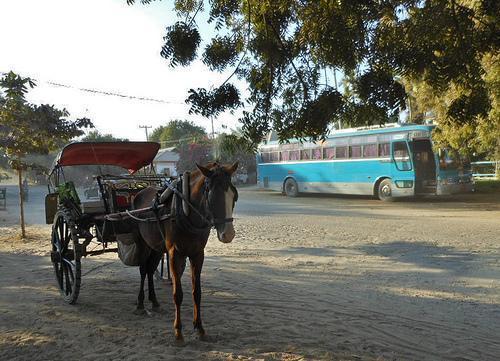How many horses?
Give a very brief answer. 1. How many wheels to the left of the horse?
Give a very brief answer. 2. 